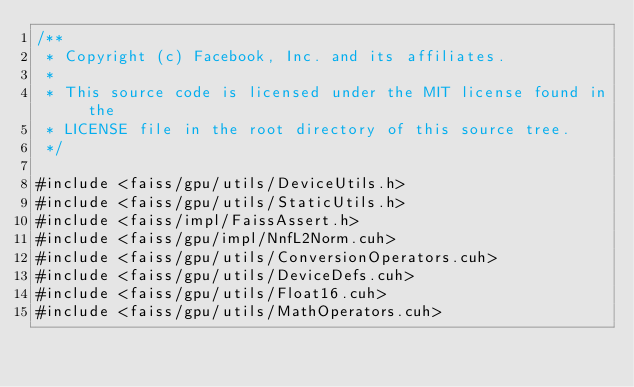Convert code to text. <code><loc_0><loc_0><loc_500><loc_500><_Cuda_>/**
 * Copyright (c) Facebook, Inc. and its affiliates.
 *
 * This source code is licensed under the MIT license found in the
 * LICENSE file in the root directory of this source tree.
 */

#include <faiss/gpu/utils/DeviceUtils.h>
#include <faiss/gpu/utils/StaticUtils.h>
#include <faiss/impl/FaissAssert.h>
#include <faiss/gpu/impl/NnfL2Norm.cuh>
#include <faiss/gpu/utils/ConversionOperators.cuh>
#include <faiss/gpu/utils/DeviceDefs.cuh>
#include <faiss/gpu/utils/Float16.cuh>
#include <faiss/gpu/utils/MathOperators.cuh></code> 